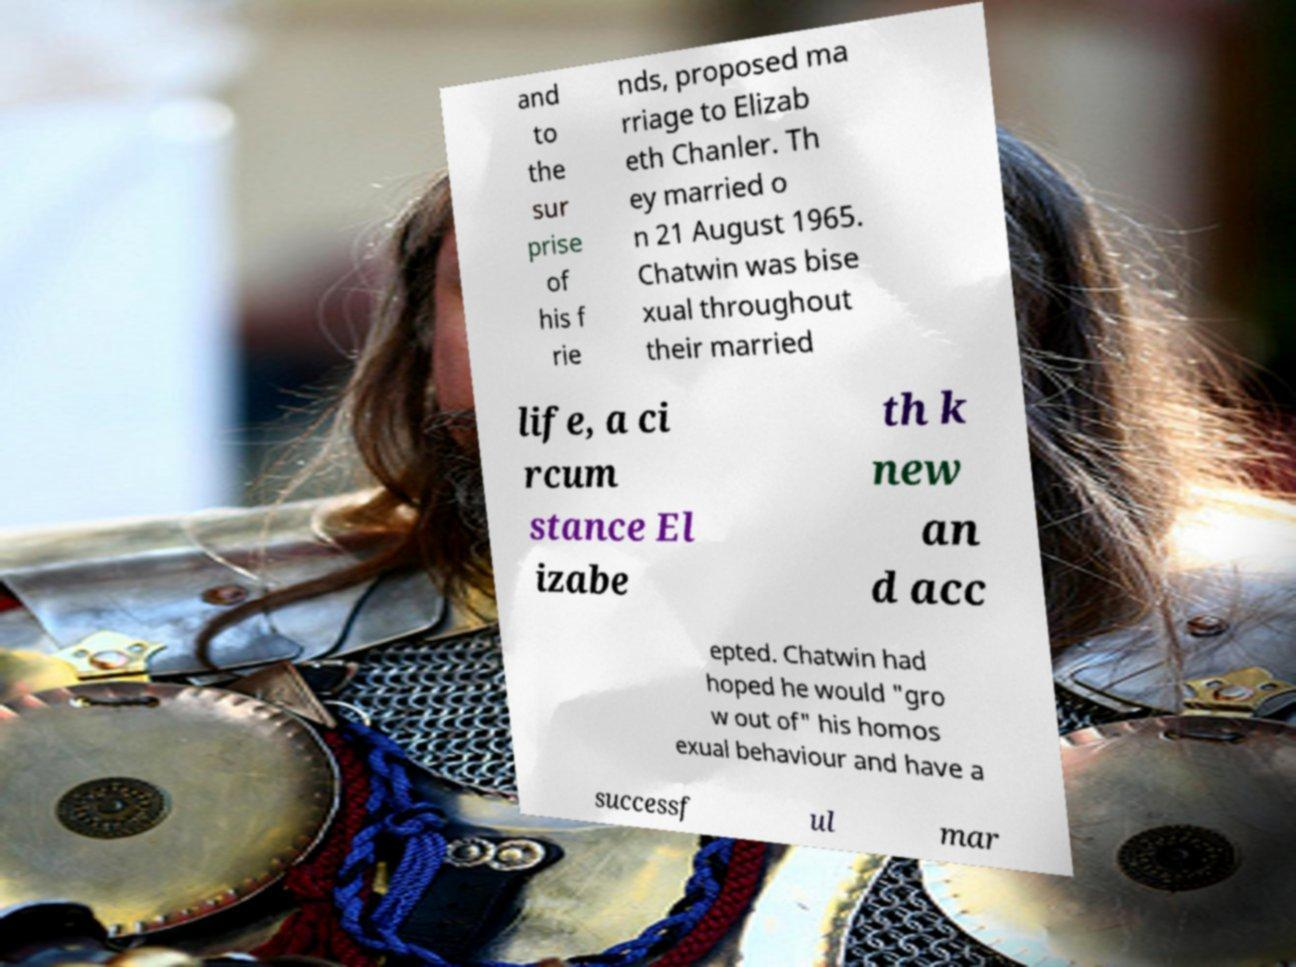Please read and relay the text visible in this image. What does it say? and to the sur prise of his f rie nds, proposed ma rriage to Elizab eth Chanler. Th ey married o n 21 August 1965. Chatwin was bise xual throughout their married life, a ci rcum stance El izabe th k new an d acc epted. Chatwin had hoped he would "gro w out of" his homos exual behaviour and have a successf ul mar 